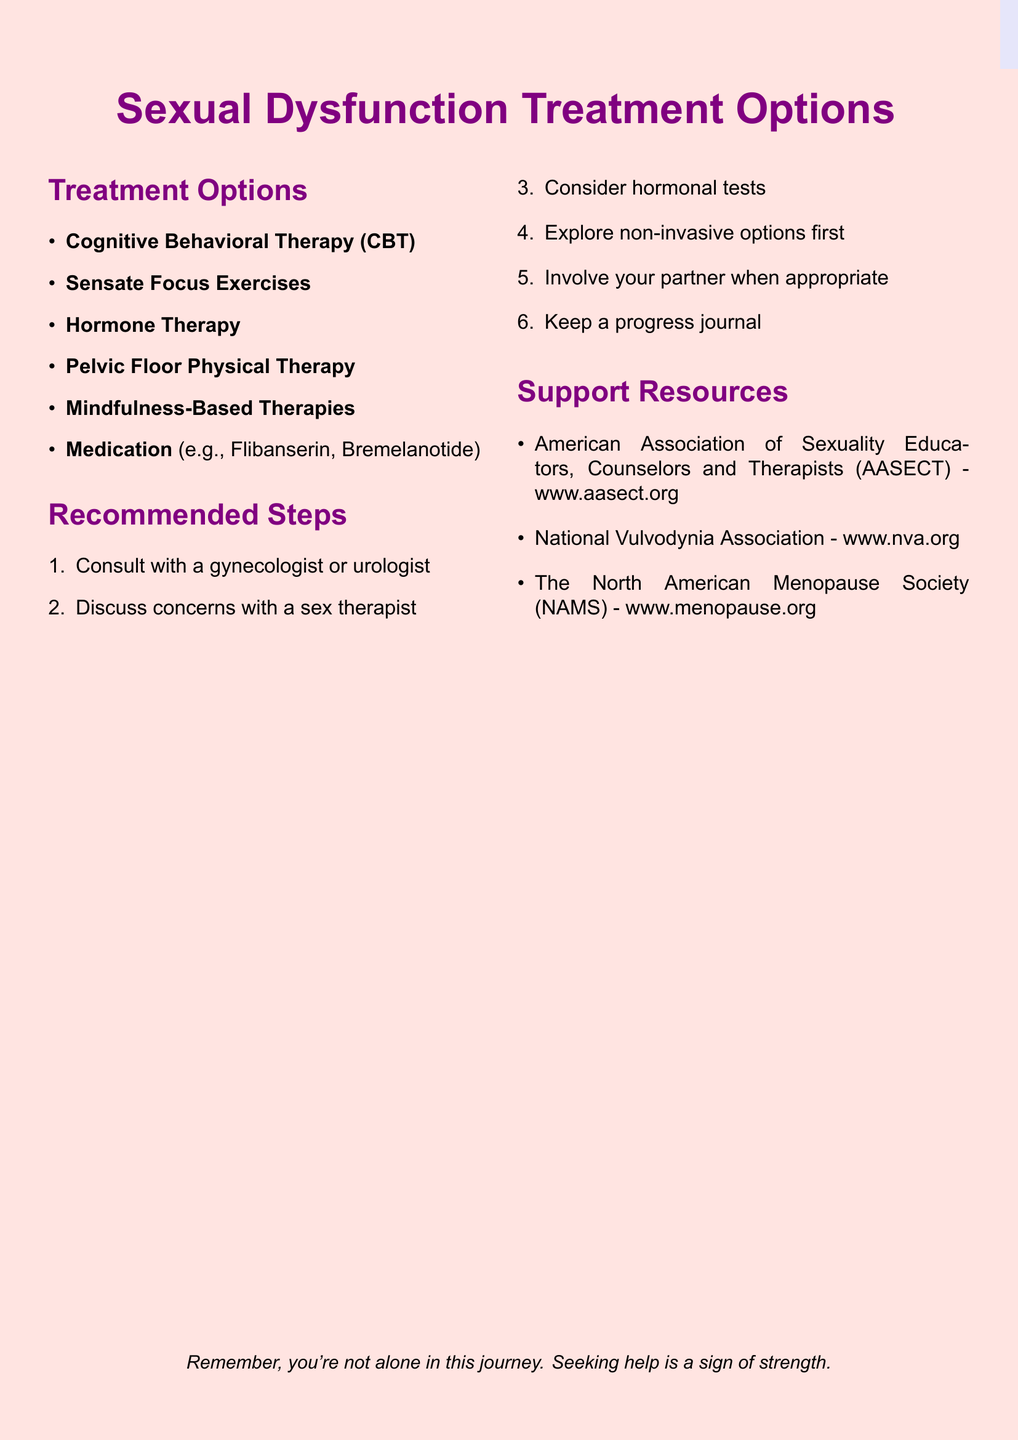What is one type of therapy mentioned for sexual dysfunction? The document lists several treatment options, one of which is Cognitive Behavioral Therapy (CBT).
Answer: Cognitive Behavioral Therapy (CBT) What benefit does Sensate Focus Exercises provide? Among the benefits listed for Sensate Focus Exercises, one is that it helps rebuild physical intimacy.
Answer: Helps rebuild physical intimacy What is a key consideration for Hormone Therapy? The document states that Hormone Therapy requires medical evaluation and ongoing monitoring as a key consideration.
Answer: Requires medical evaluation and ongoing monitoring What is one recommended step prior to considering medication? The document suggests exploring non-invasive options like CBT and Sensate Focus before considering medication.
Answer: Explore non-invasive options first Which organization provides referrals to certified sex therapists? The American Association of Sexuality Educators, Counselors and Therapists (AASECT) is mentioned as providing these referrals.
Answer: AASECT What mental health technique is used to reduce performance anxiety? Mindfulness-Based Therapies are mentioned as techniques to reduce performance anxiety.
Answer: Mindfulness-Based Therapies How many treatment options are listed in the document? The document outlines a total of six treatment options for sexual dysfunction.
Answer: Six What type of physical therapy is aimed at the pelvic floor muscles? The document mentions Pelvic Floor Physical Therapy as targeting the pelvic floor muscles.
Answer: Pelvic Floor Physical Therapy 